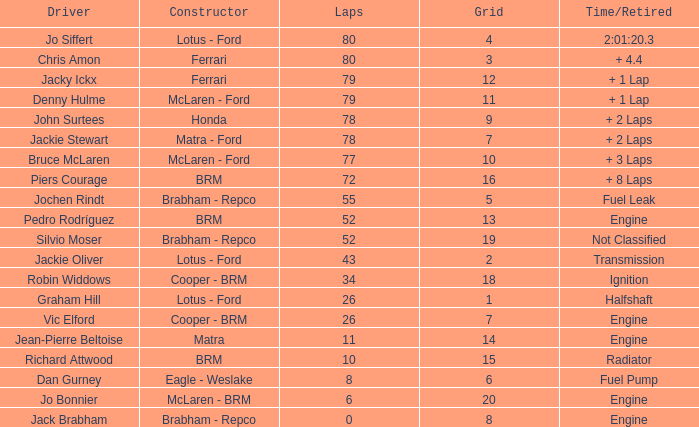What driver has a grid greater than 19? Jo Bonnier. 